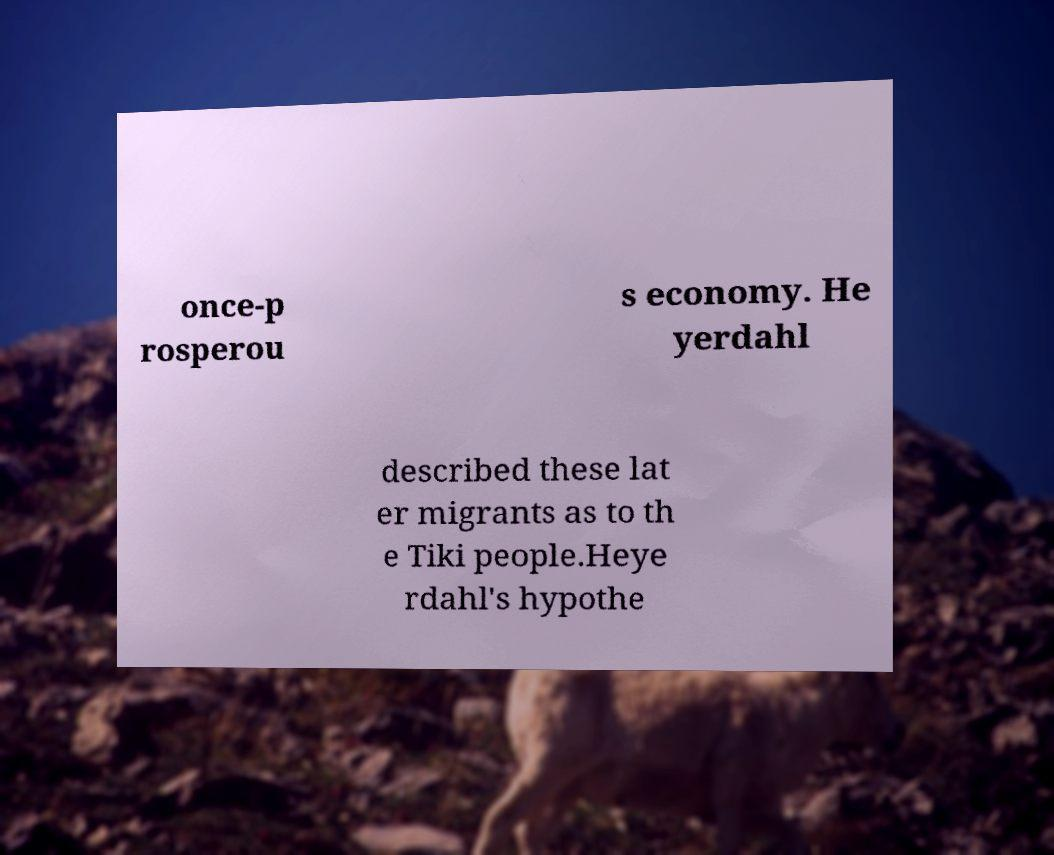There's text embedded in this image that I need extracted. Can you transcribe it verbatim? once-p rosperou s economy. He yerdahl described these lat er migrants as to th e Tiki people.Heye rdahl's hypothe 